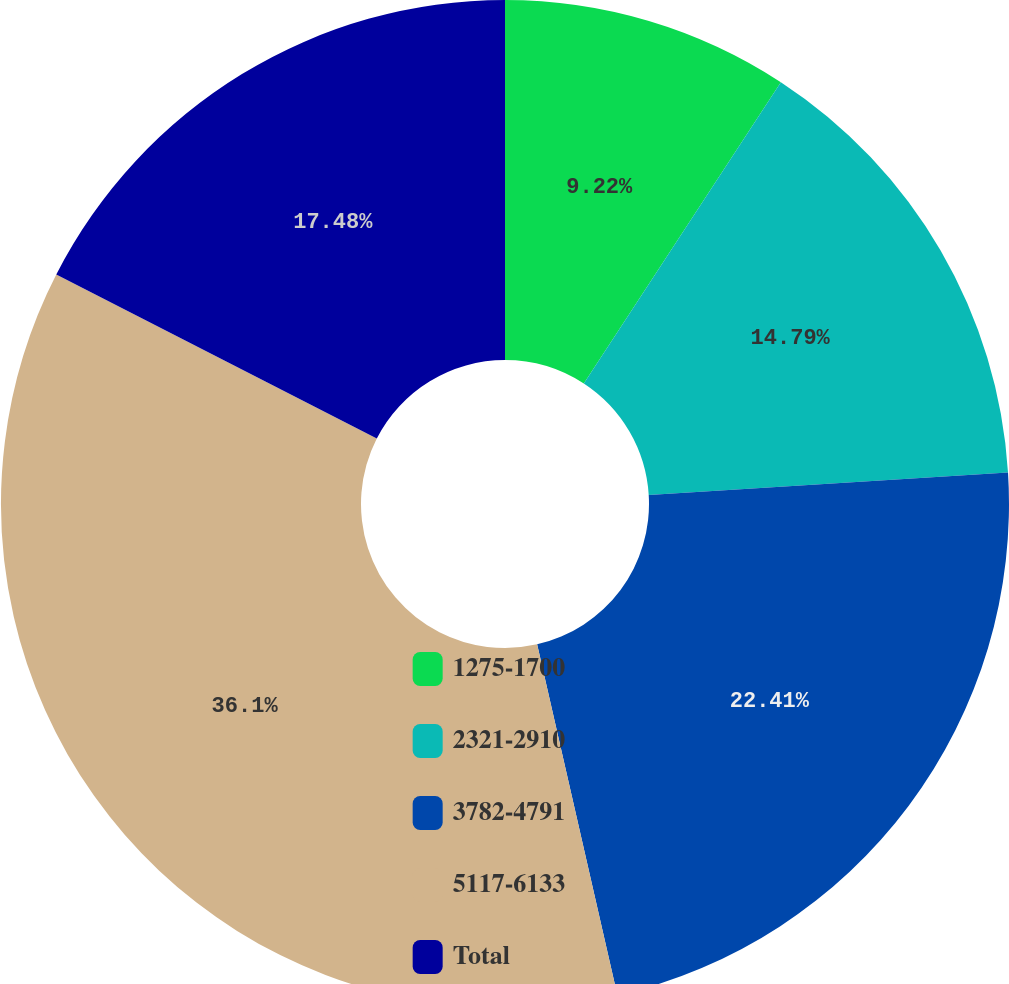Convert chart to OTSL. <chart><loc_0><loc_0><loc_500><loc_500><pie_chart><fcel>1275-1700<fcel>2321-2910<fcel>3782-4791<fcel>5117-6133<fcel>Total<nl><fcel>9.22%<fcel>14.79%<fcel>22.42%<fcel>36.11%<fcel>17.48%<nl></chart> 